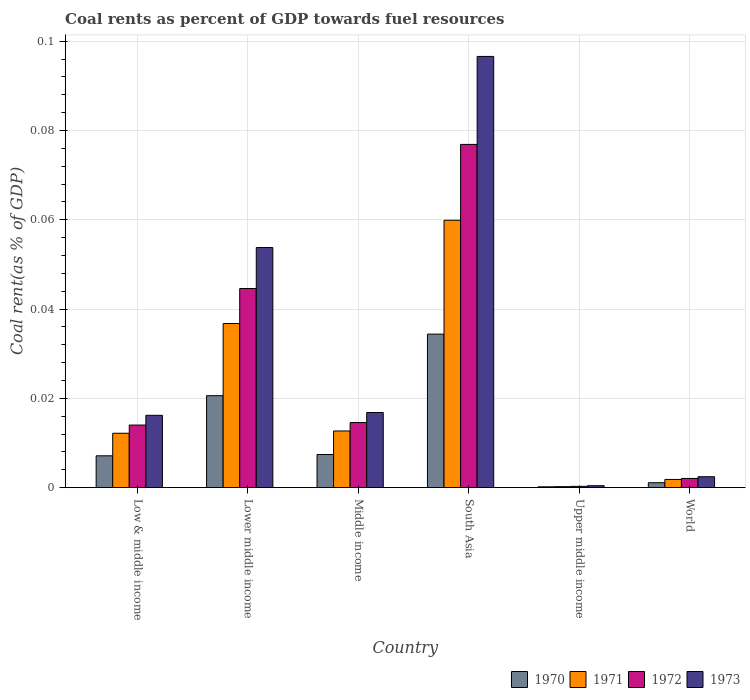How many different coloured bars are there?
Provide a short and direct response. 4. How many groups of bars are there?
Your answer should be very brief. 6. Are the number of bars on each tick of the X-axis equal?
Offer a terse response. Yes. What is the label of the 4th group of bars from the left?
Offer a very short reply. South Asia. What is the coal rent in 1972 in Upper middle income?
Keep it short and to the point. 0. Across all countries, what is the maximum coal rent in 1970?
Provide a short and direct response. 0.03. Across all countries, what is the minimum coal rent in 1971?
Your answer should be very brief. 0. In which country was the coal rent in 1970 maximum?
Offer a very short reply. South Asia. In which country was the coal rent in 1972 minimum?
Give a very brief answer. Upper middle income. What is the total coal rent in 1972 in the graph?
Ensure brevity in your answer.  0.15. What is the difference between the coal rent in 1972 in Lower middle income and that in Middle income?
Offer a very short reply. 0.03. What is the difference between the coal rent in 1972 in South Asia and the coal rent in 1970 in World?
Provide a succinct answer. 0.08. What is the average coal rent in 1972 per country?
Give a very brief answer. 0.03. What is the difference between the coal rent of/in 1970 and coal rent of/in 1973 in Low & middle income?
Your answer should be compact. -0.01. In how many countries, is the coal rent in 1970 greater than 0.092 %?
Keep it short and to the point. 0. What is the ratio of the coal rent in 1970 in South Asia to that in World?
Make the answer very short. 31.24. Is the coal rent in 1971 in Low & middle income less than that in South Asia?
Give a very brief answer. Yes. Is the difference between the coal rent in 1970 in Middle income and Upper middle income greater than the difference between the coal rent in 1973 in Middle income and Upper middle income?
Provide a succinct answer. No. What is the difference between the highest and the second highest coal rent in 1971?
Make the answer very short. 0.05. What is the difference between the highest and the lowest coal rent in 1972?
Give a very brief answer. 0.08. What does the 4th bar from the left in Low & middle income represents?
Your answer should be very brief. 1973. What does the 2nd bar from the right in World represents?
Ensure brevity in your answer.  1972. Is it the case that in every country, the sum of the coal rent in 1972 and coal rent in 1971 is greater than the coal rent in 1970?
Your answer should be very brief. Yes. How many bars are there?
Your answer should be compact. 24. Are the values on the major ticks of Y-axis written in scientific E-notation?
Your answer should be very brief. No. Does the graph contain any zero values?
Your response must be concise. No. Where does the legend appear in the graph?
Your answer should be very brief. Bottom right. How many legend labels are there?
Make the answer very short. 4. How are the legend labels stacked?
Your answer should be very brief. Horizontal. What is the title of the graph?
Offer a terse response. Coal rents as percent of GDP towards fuel resources. What is the label or title of the Y-axis?
Ensure brevity in your answer.  Coal rent(as % of GDP). What is the Coal rent(as % of GDP) in 1970 in Low & middle income?
Provide a short and direct response. 0.01. What is the Coal rent(as % of GDP) of 1971 in Low & middle income?
Ensure brevity in your answer.  0.01. What is the Coal rent(as % of GDP) in 1972 in Low & middle income?
Provide a short and direct response. 0.01. What is the Coal rent(as % of GDP) in 1973 in Low & middle income?
Offer a very short reply. 0.02. What is the Coal rent(as % of GDP) in 1970 in Lower middle income?
Provide a succinct answer. 0.02. What is the Coal rent(as % of GDP) in 1971 in Lower middle income?
Offer a terse response. 0.04. What is the Coal rent(as % of GDP) of 1972 in Lower middle income?
Your response must be concise. 0.04. What is the Coal rent(as % of GDP) of 1973 in Lower middle income?
Make the answer very short. 0.05. What is the Coal rent(as % of GDP) of 1970 in Middle income?
Keep it short and to the point. 0.01. What is the Coal rent(as % of GDP) in 1971 in Middle income?
Keep it short and to the point. 0.01. What is the Coal rent(as % of GDP) in 1972 in Middle income?
Make the answer very short. 0.01. What is the Coal rent(as % of GDP) of 1973 in Middle income?
Give a very brief answer. 0.02. What is the Coal rent(as % of GDP) in 1970 in South Asia?
Offer a very short reply. 0.03. What is the Coal rent(as % of GDP) in 1971 in South Asia?
Offer a very short reply. 0.06. What is the Coal rent(as % of GDP) of 1972 in South Asia?
Offer a terse response. 0.08. What is the Coal rent(as % of GDP) in 1973 in South Asia?
Offer a very short reply. 0.1. What is the Coal rent(as % of GDP) in 1970 in Upper middle income?
Your answer should be very brief. 0. What is the Coal rent(as % of GDP) of 1971 in Upper middle income?
Give a very brief answer. 0. What is the Coal rent(as % of GDP) of 1972 in Upper middle income?
Offer a terse response. 0. What is the Coal rent(as % of GDP) in 1973 in Upper middle income?
Provide a short and direct response. 0. What is the Coal rent(as % of GDP) in 1970 in World?
Ensure brevity in your answer.  0. What is the Coal rent(as % of GDP) of 1971 in World?
Your answer should be compact. 0. What is the Coal rent(as % of GDP) of 1972 in World?
Give a very brief answer. 0. What is the Coal rent(as % of GDP) in 1973 in World?
Your response must be concise. 0. Across all countries, what is the maximum Coal rent(as % of GDP) of 1970?
Your answer should be very brief. 0.03. Across all countries, what is the maximum Coal rent(as % of GDP) of 1971?
Your response must be concise. 0.06. Across all countries, what is the maximum Coal rent(as % of GDP) in 1972?
Offer a terse response. 0.08. Across all countries, what is the maximum Coal rent(as % of GDP) of 1973?
Keep it short and to the point. 0.1. Across all countries, what is the minimum Coal rent(as % of GDP) of 1970?
Your answer should be compact. 0. Across all countries, what is the minimum Coal rent(as % of GDP) in 1971?
Your answer should be very brief. 0. Across all countries, what is the minimum Coal rent(as % of GDP) of 1972?
Offer a terse response. 0. Across all countries, what is the minimum Coal rent(as % of GDP) of 1973?
Your answer should be compact. 0. What is the total Coal rent(as % of GDP) of 1970 in the graph?
Provide a succinct answer. 0.07. What is the total Coal rent(as % of GDP) of 1971 in the graph?
Offer a very short reply. 0.12. What is the total Coal rent(as % of GDP) in 1972 in the graph?
Your answer should be very brief. 0.15. What is the total Coal rent(as % of GDP) of 1973 in the graph?
Provide a short and direct response. 0.19. What is the difference between the Coal rent(as % of GDP) in 1970 in Low & middle income and that in Lower middle income?
Give a very brief answer. -0.01. What is the difference between the Coal rent(as % of GDP) of 1971 in Low & middle income and that in Lower middle income?
Provide a succinct answer. -0.02. What is the difference between the Coal rent(as % of GDP) in 1972 in Low & middle income and that in Lower middle income?
Offer a terse response. -0.03. What is the difference between the Coal rent(as % of GDP) of 1973 in Low & middle income and that in Lower middle income?
Give a very brief answer. -0.04. What is the difference between the Coal rent(as % of GDP) in 1970 in Low & middle income and that in Middle income?
Offer a terse response. -0. What is the difference between the Coal rent(as % of GDP) of 1971 in Low & middle income and that in Middle income?
Make the answer very short. -0. What is the difference between the Coal rent(as % of GDP) of 1972 in Low & middle income and that in Middle income?
Your answer should be very brief. -0. What is the difference between the Coal rent(as % of GDP) of 1973 in Low & middle income and that in Middle income?
Ensure brevity in your answer.  -0. What is the difference between the Coal rent(as % of GDP) of 1970 in Low & middle income and that in South Asia?
Give a very brief answer. -0.03. What is the difference between the Coal rent(as % of GDP) in 1971 in Low & middle income and that in South Asia?
Your answer should be very brief. -0.05. What is the difference between the Coal rent(as % of GDP) of 1972 in Low & middle income and that in South Asia?
Provide a succinct answer. -0.06. What is the difference between the Coal rent(as % of GDP) of 1973 in Low & middle income and that in South Asia?
Offer a very short reply. -0.08. What is the difference between the Coal rent(as % of GDP) in 1970 in Low & middle income and that in Upper middle income?
Your answer should be very brief. 0.01. What is the difference between the Coal rent(as % of GDP) in 1971 in Low & middle income and that in Upper middle income?
Keep it short and to the point. 0.01. What is the difference between the Coal rent(as % of GDP) in 1972 in Low & middle income and that in Upper middle income?
Your answer should be compact. 0.01. What is the difference between the Coal rent(as % of GDP) of 1973 in Low & middle income and that in Upper middle income?
Make the answer very short. 0.02. What is the difference between the Coal rent(as % of GDP) in 1970 in Low & middle income and that in World?
Your answer should be compact. 0.01. What is the difference between the Coal rent(as % of GDP) of 1971 in Low & middle income and that in World?
Offer a terse response. 0.01. What is the difference between the Coal rent(as % of GDP) of 1972 in Low & middle income and that in World?
Give a very brief answer. 0.01. What is the difference between the Coal rent(as % of GDP) of 1973 in Low & middle income and that in World?
Keep it short and to the point. 0.01. What is the difference between the Coal rent(as % of GDP) of 1970 in Lower middle income and that in Middle income?
Provide a succinct answer. 0.01. What is the difference between the Coal rent(as % of GDP) in 1971 in Lower middle income and that in Middle income?
Your answer should be very brief. 0.02. What is the difference between the Coal rent(as % of GDP) in 1973 in Lower middle income and that in Middle income?
Offer a very short reply. 0.04. What is the difference between the Coal rent(as % of GDP) of 1970 in Lower middle income and that in South Asia?
Offer a terse response. -0.01. What is the difference between the Coal rent(as % of GDP) in 1971 in Lower middle income and that in South Asia?
Offer a terse response. -0.02. What is the difference between the Coal rent(as % of GDP) in 1972 in Lower middle income and that in South Asia?
Offer a terse response. -0.03. What is the difference between the Coal rent(as % of GDP) in 1973 in Lower middle income and that in South Asia?
Your response must be concise. -0.04. What is the difference between the Coal rent(as % of GDP) of 1970 in Lower middle income and that in Upper middle income?
Offer a very short reply. 0.02. What is the difference between the Coal rent(as % of GDP) in 1971 in Lower middle income and that in Upper middle income?
Your answer should be compact. 0.04. What is the difference between the Coal rent(as % of GDP) in 1972 in Lower middle income and that in Upper middle income?
Ensure brevity in your answer.  0.04. What is the difference between the Coal rent(as % of GDP) in 1973 in Lower middle income and that in Upper middle income?
Offer a very short reply. 0.05. What is the difference between the Coal rent(as % of GDP) of 1970 in Lower middle income and that in World?
Make the answer very short. 0.02. What is the difference between the Coal rent(as % of GDP) of 1971 in Lower middle income and that in World?
Your answer should be very brief. 0.03. What is the difference between the Coal rent(as % of GDP) of 1972 in Lower middle income and that in World?
Provide a succinct answer. 0.04. What is the difference between the Coal rent(as % of GDP) of 1973 in Lower middle income and that in World?
Provide a short and direct response. 0.05. What is the difference between the Coal rent(as % of GDP) in 1970 in Middle income and that in South Asia?
Keep it short and to the point. -0.03. What is the difference between the Coal rent(as % of GDP) in 1971 in Middle income and that in South Asia?
Offer a terse response. -0.05. What is the difference between the Coal rent(as % of GDP) of 1972 in Middle income and that in South Asia?
Offer a very short reply. -0.06. What is the difference between the Coal rent(as % of GDP) in 1973 in Middle income and that in South Asia?
Make the answer very short. -0.08. What is the difference between the Coal rent(as % of GDP) of 1970 in Middle income and that in Upper middle income?
Provide a succinct answer. 0.01. What is the difference between the Coal rent(as % of GDP) in 1971 in Middle income and that in Upper middle income?
Make the answer very short. 0.01. What is the difference between the Coal rent(as % of GDP) in 1972 in Middle income and that in Upper middle income?
Offer a terse response. 0.01. What is the difference between the Coal rent(as % of GDP) in 1973 in Middle income and that in Upper middle income?
Keep it short and to the point. 0.02. What is the difference between the Coal rent(as % of GDP) of 1970 in Middle income and that in World?
Provide a short and direct response. 0.01. What is the difference between the Coal rent(as % of GDP) of 1971 in Middle income and that in World?
Your answer should be very brief. 0.01. What is the difference between the Coal rent(as % of GDP) of 1972 in Middle income and that in World?
Your response must be concise. 0.01. What is the difference between the Coal rent(as % of GDP) of 1973 in Middle income and that in World?
Your answer should be compact. 0.01. What is the difference between the Coal rent(as % of GDP) of 1970 in South Asia and that in Upper middle income?
Offer a terse response. 0.03. What is the difference between the Coal rent(as % of GDP) in 1971 in South Asia and that in Upper middle income?
Offer a terse response. 0.06. What is the difference between the Coal rent(as % of GDP) of 1972 in South Asia and that in Upper middle income?
Ensure brevity in your answer.  0.08. What is the difference between the Coal rent(as % of GDP) of 1973 in South Asia and that in Upper middle income?
Your response must be concise. 0.1. What is the difference between the Coal rent(as % of GDP) in 1971 in South Asia and that in World?
Provide a succinct answer. 0.06. What is the difference between the Coal rent(as % of GDP) in 1972 in South Asia and that in World?
Offer a very short reply. 0.07. What is the difference between the Coal rent(as % of GDP) in 1973 in South Asia and that in World?
Keep it short and to the point. 0.09. What is the difference between the Coal rent(as % of GDP) of 1970 in Upper middle income and that in World?
Your answer should be very brief. -0. What is the difference between the Coal rent(as % of GDP) of 1971 in Upper middle income and that in World?
Your answer should be very brief. -0. What is the difference between the Coal rent(as % of GDP) of 1972 in Upper middle income and that in World?
Offer a very short reply. -0. What is the difference between the Coal rent(as % of GDP) in 1973 in Upper middle income and that in World?
Provide a succinct answer. -0. What is the difference between the Coal rent(as % of GDP) in 1970 in Low & middle income and the Coal rent(as % of GDP) in 1971 in Lower middle income?
Provide a succinct answer. -0.03. What is the difference between the Coal rent(as % of GDP) of 1970 in Low & middle income and the Coal rent(as % of GDP) of 1972 in Lower middle income?
Offer a terse response. -0.04. What is the difference between the Coal rent(as % of GDP) of 1970 in Low & middle income and the Coal rent(as % of GDP) of 1973 in Lower middle income?
Your response must be concise. -0.05. What is the difference between the Coal rent(as % of GDP) of 1971 in Low & middle income and the Coal rent(as % of GDP) of 1972 in Lower middle income?
Provide a short and direct response. -0.03. What is the difference between the Coal rent(as % of GDP) of 1971 in Low & middle income and the Coal rent(as % of GDP) of 1973 in Lower middle income?
Provide a succinct answer. -0.04. What is the difference between the Coal rent(as % of GDP) in 1972 in Low & middle income and the Coal rent(as % of GDP) in 1973 in Lower middle income?
Your answer should be very brief. -0.04. What is the difference between the Coal rent(as % of GDP) of 1970 in Low & middle income and the Coal rent(as % of GDP) of 1971 in Middle income?
Ensure brevity in your answer.  -0.01. What is the difference between the Coal rent(as % of GDP) in 1970 in Low & middle income and the Coal rent(as % of GDP) in 1972 in Middle income?
Provide a short and direct response. -0.01. What is the difference between the Coal rent(as % of GDP) in 1970 in Low & middle income and the Coal rent(as % of GDP) in 1973 in Middle income?
Your response must be concise. -0.01. What is the difference between the Coal rent(as % of GDP) of 1971 in Low & middle income and the Coal rent(as % of GDP) of 1972 in Middle income?
Make the answer very short. -0. What is the difference between the Coal rent(as % of GDP) of 1971 in Low & middle income and the Coal rent(as % of GDP) of 1973 in Middle income?
Keep it short and to the point. -0. What is the difference between the Coal rent(as % of GDP) of 1972 in Low & middle income and the Coal rent(as % of GDP) of 1973 in Middle income?
Your answer should be compact. -0. What is the difference between the Coal rent(as % of GDP) of 1970 in Low & middle income and the Coal rent(as % of GDP) of 1971 in South Asia?
Give a very brief answer. -0.05. What is the difference between the Coal rent(as % of GDP) in 1970 in Low & middle income and the Coal rent(as % of GDP) in 1972 in South Asia?
Your response must be concise. -0.07. What is the difference between the Coal rent(as % of GDP) in 1970 in Low & middle income and the Coal rent(as % of GDP) in 1973 in South Asia?
Offer a very short reply. -0.09. What is the difference between the Coal rent(as % of GDP) in 1971 in Low & middle income and the Coal rent(as % of GDP) in 1972 in South Asia?
Keep it short and to the point. -0.06. What is the difference between the Coal rent(as % of GDP) of 1971 in Low & middle income and the Coal rent(as % of GDP) of 1973 in South Asia?
Provide a short and direct response. -0.08. What is the difference between the Coal rent(as % of GDP) in 1972 in Low & middle income and the Coal rent(as % of GDP) in 1973 in South Asia?
Provide a short and direct response. -0.08. What is the difference between the Coal rent(as % of GDP) of 1970 in Low & middle income and the Coal rent(as % of GDP) of 1971 in Upper middle income?
Give a very brief answer. 0.01. What is the difference between the Coal rent(as % of GDP) of 1970 in Low & middle income and the Coal rent(as % of GDP) of 1972 in Upper middle income?
Your answer should be compact. 0.01. What is the difference between the Coal rent(as % of GDP) in 1970 in Low & middle income and the Coal rent(as % of GDP) in 1973 in Upper middle income?
Give a very brief answer. 0.01. What is the difference between the Coal rent(as % of GDP) of 1971 in Low & middle income and the Coal rent(as % of GDP) of 1972 in Upper middle income?
Keep it short and to the point. 0.01. What is the difference between the Coal rent(as % of GDP) of 1971 in Low & middle income and the Coal rent(as % of GDP) of 1973 in Upper middle income?
Provide a succinct answer. 0.01. What is the difference between the Coal rent(as % of GDP) in 1972 in Low & middle income and the Coal rent(as % of GDP) in 1973 in Upper middle income?
Your response must be concise. 0.01. What is the difference between the Coal rent(as % of GDP) in 1970 in Low & middle income and the Coal rent(as % of GDP) in 1971 in World?
Provide a succinct answer. 0.01. What is the difference between the Coal rent(as % of GDP) of 1970 in Low & middle income and the Coal rent(as % of GDP) of 1972 in World?
Give a very brief answer. 0.01. What is the difference between the Coal rent(as % of GDP) of 1970 in Low & middle income and the Coal rent(as % of GDP) of 1973 in World?
Give a very brief answer. 0. What is the difference between the Coal rent(as % of GDP) in 1971 in Low & middle income and the Coal rent(as % of GDP) in 1972 in World?
Provide a succinct answer. 0.01. What is the difference between the Coal rent(as % of GDP) of 1971 in Low & middle income and the Coal rent(as % of GDP) of 1973 in World?
Keep it short and to the point. 0.01. What is the difference between the Coal rent(as % of GDP) of 1972 in Low & middle income and the Coal rent(as % of GDP) of 1973 in World?
Your answer should be compact. 0.01. What is the difference between the Coal rent(as % of GDP) in 1970 in Lower middle income and the Coal rent(as % of GDP) in 1971 in Middle income?
Your answer should be compact. 0.01. What is the difference between the Coal rent(as % of GDP) of 1970 in Lower middle income and the Coal rent(as % of GDP) of 1972 in Middle income?
Offer a very short reply. 0.01. What is the difference between the Coal rent(as % of GDP) of 1970 in Lower middle income and the Coal rent(as % of GDP) of 1973 in Middle income?
Your response must be concise. 0. What is the difference between the Coal rent(as % of GDP) in 1971 in Lower middle income and the Coal rent(as % of GDP) in 1972 in Middle income?
Offer a very short reply. 0.02. What is the difference between the Coal rent(as % of GDP) in 1971 in Lower middle income and the Coal rent(as % of GDP) in 1973 in Middle income?
Make the answer very short. 0.02. What is the difference between the Coal rent(as % of GDP) of 1972 in Lower middle income and the Coal rent(as % of GDP) of 1973 in Middle income?
Make the answer very short. 0.03. What is the difference between the Coal rent(as % of GDP) in 1970 in Lower middle income and the Coal rent(as % of GDP) in 1971 in South Asia?
Provide a succinct answer. -0.04. What is the difference between the Coal rent(as % of GDP) of 1970 in Lower middle income and the Coal rent(as % of GDP) of 1972 in South Asia?
Give a very brief answer. -0.06. What is the difference between the Coal rent(as % of GDP) of 1970 in Lower middle income and the Coal rent(as % of GDP) of 1973 in South Asia?
Your answer should be compact. -0.08. What is the difference between the Coal rent(as % of GDP) of 1971 in Lower middle income and the Coal rent(as % of GDP) of 1972 in South Asia?
Offer a very short reply. -0.04. What is the difference between the Coal rent(as % of GDP) in 1971 in Lower middle income and the Coal rent(as % of GDP) in 1973 in South Asia?
Offer a very short reply. -0.06. What is the difference between the Coal rent(as % of GDP) in 1972 in Lower middle income and the Coal rent(as % of GDP) in 1973 in South Asia?
Provide a succinct answer. -0.05. What is the difference between the Coal rent(as % of GDP) in 1970 in Lower middle income and the Coal rent(as % of GDP) in 1971 in Upper middle income?
Your answer should be compact. 0.02. What is the difference between the Coal rent(as % of GDP) in 1970 in Lower middle income and the Coal rent(as % of GDP) in 1972 in Upper middle income?
Give a very brief answer. 0.02. What is the difference between the Coal rent(as % of GDP) in 1970 in Lower middle income and the Coal rent(as % of GDP) in 1973 in Upper middle income?
Ensure brevity in your answer.  0.02. What is the difference between the Coal rent(as % of GDP) in 1971 in Lower middle income and the Coal rent(as % of GDP) in 1972 in Upper middle income?
Your response must be concise. 0.04. What is the difference between the Coal rent(as % of GDP) of 1971 in Lower middle income and the Coal rent(as % of GDP) of 1973 in Upper middle income?
Give a very brief answer. 0.04. What is the difference between the Coal rent(as % of GDP) in 1972 in Lower middle income and the Coal rent(as % of GDP) in 1973 in Upper middle income?
Give a very brief answer. 0.04. What is the difference between the Coal rent(as % of GDP) of 1970 in Lower middle income and the Coal rent(as % of GDP) of 1971 in World?
Provide a succinct answer. 0.02. What is the difference between the Coal rent(as % of GDP) of 1970 in Lower middle income and the Coal rent(as % of GDP) of 1972 in World?
Offer a very short reply. 0.02. What is the difference between the Coal rent(as % of GDP) in 1970 in Lower middle income and the Coal rent(as % of GDP) in 1973 in World?
Provide a short and direct response. 0.02. What is the difference between the Coal rent(as % of GDP) in 1971 in Lower middle income and the Coal rent(as % of GDP) in 1972 in World?
Your response must be concise. 0.03. What is the difference between the Coal rent(as % of GDP) of 1971 in Lower middle income and the Coal rent(as % of GDP) of 1973 in World?
Offer a terse response. 0.03. What is the difference between the Coal rent(as % of GDP) of 1972 in Lower middle income and the Coal rent(as % of GDP) of 1973 in World?
Your response must be concise. 0.04. What is the difference between the Coal rent(as % of GDP) in 1970 in Middle income and the Coal rent(as % of GDP) in 1971 in South Asia?
Your answer should be very brief. -0.05. What is the difference between the Coal rent(as % of GDP) in 1970 in Middle income and the Coal rent(as % of GDP) in 1972 in South Asia?
Provide a succinct answer. -0.07. What is the difference between the Coal rent(as % of GDP) of 1970 in Middle income and the Coal rent(as % of GDP) of 1973 in South Asia?
Make the answer very short. -0.09. What is the difference between the Coal rent(as % of GDP) in 1971 in Middle income and the Coal rent(as % of GDP) in 1972 in South Asia?
Provide a succinct answer. -0.06. What is the difference between the Coal rent(as % of GDP) in 1971 in Middle income and the Coal rent(as % of GDP) in 1973 in South Asia?
Provide a succinct answer. -0.08. What is the difference between the Coal rent(as % of GDP) of 1972 in Middle income and the Coal rent(as % of GDP) of 1973 in South Asia?
Keep it short and to the point. -0.08. What is the difference between the Coal rent(as % of GDP) of 1970 in Middle income and the Coal rent(as % of GDP) of 1971 in Upper middle income?
Keep it short and to the point. 0.01. What is the difference between the Coal rent(as % of GDP) in 1970 in Middle income and the Coal rent(as % of GDP) in 1972 in Upper middle income?
Offer a very short reply. 0.01. What is the difference between the Coal rent(as % of GDP) of 1970 in Middle income and the Coal rent(as % of GDP) of 1973 in Upper middle income?
Give a very brief answer. 0.01. What is the difference between the Coal rent(as % of GDP) of 1971 in Middle income and the Coal rent(as % of GDP) of 1972 in Upper middle income?
Offer a terse response. 0.01. What is the difference between the Coal rent(as % of GDP) of 1971 in Middle income and the Coal rent(as % of GDP) of 1973 in Upper middle income?
Ensure brevity in your answer.  0.01. What is the difference between the Coal rent(as % of GDP) in 1972 in Middle income and the Coal rent(as % of GDP) in 1973 in Upper middle income?
Give a very brief answer. 0.01. What is the difference between the Coal rent(as % of GDP) in 1970 in Middle income and the Coal rent(as % of GDP) in 1971 in World?
Offer a terse response. 0.01. What is the difference between the Coal rent(as % of GDP) in 1970 in Middle income and the Coal rent(as % of GDP) in 1972 in World?
Give a very brief answer. 0.01. What is the difference between the Coal rent(as % of GDP) in 1970 in Middle income and the Coal rent(as % of GDP) in 1973 in World?
Your answer should be compact. 0.01. What is the difference between the Coal rent(as % of GDP) in 1971 in Middle income and the Coal rent(as % of GDP) in 1972 in World?
Offer a very short reply. 0.01. What is the difference between the Coal rent(as % of GDP) of 1971 in Middle income and the Coal rent(as % of GDP) of 1973 in World?
Your answer should be very brief. 0.01. What is the difference between the Coal rent(as % of GDP) in 1972 in Middle income and the Coal rent(as % of GDP) in 1973 in World?
Provide a succinct answer. 0.01. What is the difference between the Coal rent(as % of GDP) in 1970 in South Asia and the Coal rent(as % of GDP) in 1971 in Upper middle income?
Keep it short and to the point. 0.03. What is the difference between the Coal rent(as % of GDP) in 1970 in South Asia and the Coal rent(as % of GDP) in 1972 in Upper middle income?
Make the answer very short. 0.03. What is the difference between the Coal rent(as % of GDP) of 1970 in South Asia and the Coal rent(as % of GDP) of 1973 in Upper middle income?
Ensure brevity in your answer.  0.03. What is the difference between the Coal rent(as % of GDP) of 1971 in South Asia and the Coal rent(as % of GDP) of 1972 in Upper middle income?
Your answer should be very brief. 0.06. What is the difference between the Coal rent(as % of GDP) in 1971 in South Asia and the Coal rent(as % of GDP) in 1973 in Upper middle income?
Offer a terse response. 0.06. What is the difference between the Coal rent(as % of GDP) in 1972 in South Asia and the Coal rent(as % of GDP) in 1973 in Upper middle income?
Your answer should be compact. 0.08. What is the difference between the Coal rent(as % of GDP) in 1970 in South Asia and the Coal rent(as % of GDP) in 1971 in World?
Provide a succinct answer. 0.03. What is the difference between the Coal rent(as % of GDP) of 1970 in South Asia and the Coal rent(as % of GDP) of 1972 in World?
Give a very brief answer. 0.03. What is the difference between the Coal rent(as % of GDP) in 1970 in South Asia and the Coal rent(as % of GDP) in 1973 in World?
Your answer should be very brief. 0.03. What is the difference between the Coal rent(as % of GDP) in 1971 in South Asia and the Coal rent(as % of GDP) in 1972 in World?
Your answer should be very brief. 0.06. What is the difference between the Coal rent(as % of GDP) in 1971 in South Asia and the Coal rent(as % of GDP) in 1973 in World?
Ensure brevity in your answer.  0.06. What is the difference between the Coal rent(as % of GDP) in 1972 in South Asia and the Coal rent(as % of GDP) in 1973 in World?
Your answer should be compact. 0.07. What is the difference between the Coal rent(as % of GDP) of 1970 in Upper middle income and the Coal rent(as % of GDP) of 1971 in World?
Make the answer very short. -0. What is the difference between the Coal rent(as % of GDP) of 1970 in Upper middle income and the Coal rent(as % of GDP) of 1972 in World?
Your answer should be compact. -0. What is the difference between the Coal rent(as % of GDP) of 1970 in Upper middle income and the Coal rent(as % of GDP) of 1973 in World?
Give a very brief answer. -0. What is the difference between the Coal rent(as % of GDP) of 1971 in Upper middle income and the Coal rent(as % of GDP) of 1972 in World?
Provide a short and direct response. -0. What is the difference between the Coal rent(as % of GDP) of 1971 in Upper middle income and the Coal rent(as % of GDP) of 1973 in World?
Make the answer very short. -0. What is the difference between the Coal rent(as % of GDP) of 1972 in Upper middle income and the Coal rent(as % of GDP) of 1973 in World?
Your answer should be compact. -0. What is the average Coal rent(as % of GDP) in 1970 per country?
Keep it short and to the point. 0.01. What is the average Coal rent(as % of GDP) in 1971 per country?
Your response must be concise. 0.02. What is the average Coal rent(as % of GDP) in 1972 per country?
Offer a very short reply. 0.03. What is the average Coal rent(as % of GDP) of 1973 per country?
Offer a very short reply. 0.03. What is the difference between the Coal rent(as % of GDP) in 1970 and Coal rent(as % of GDP) in 1971 in Low & middle income?
Your answer should be very brief. -0.01. What is the difference between the Coal rent(as % of GDP) of 1970 and Coal rent(as % of GDP) of 1972 in Low & middle income?
Offer a terse response. -0.01. What is the difference between the Coal rent(as % of GDP) of 1970 and Coal rent(as % of GDP) of 1973 in Low & middle income?
Offer a very short reply. -0.01. What is the difference between the Coal rent(as % of GDP) in 1971 and Coal rent(as % of GDP) in 1972 in Low & middle income?
Provide a short and direct response. -0. What is the difference between the Coal rent(as % of GDP) of 1971 and Coal rent(as % of GDP) of 1973 in Low & middle income?
Give a very brief answer. -0. What is the difference between the Coal rent(as % of GDP) in 1972 and Coal rent(as % of GDP) in 1973 in Low & middle income?
Your response must be concise. -0. What is the difference between the Coal rent(as % of GDP) in 1970 and Coal rent(as % of GDP) in 1971 in Lower middle income?
Keep it short and to the point. -0.02. What is the difference between the Coal rent(as % of GDP) of 1970 and Coal rent(as % of GDP) of 1972 in Lower middle income?
Your response must be concise. -0.02. What is the difference between the Coal rent(as % of GDP) in 1970 and Coal rent(as % of GDP) in 1973 in Lower middle income?
Your response must be concise. -0.03. What is the difference between the Coal rent(as % of GDP) in 1971 and Coal rent(as % of GDP) in 1972 in Lower middle income?
Your answer should be compact. -0.01. What is the difference between the Coal rent(as % of GDP) in 1971 and Coal rent(as % of GDP) in 1973 in Lower middle income?
Your answer should be compact. -0.02. What is the difference between the Coal rent(as % of GDP) of 1972 and Coal rent(as % of GDP) of 1973 in Lower middle income?
Make the answer very short. -0.01. What is the difference between the Coal rent(as % of GDP) in 1970 and Coal rent(as % of GDP) in 1971 in Middle income?
Provide a succinct answer. -0.01. What is the difference between the Coal rent(as % of GDP) of 1970 and Coal rent(as % of GDP) of 1972 in Middle income?
Your answer should be very brief. -0.01. What is the difference between the Coal rent(as % of GDP) of 1970 and Coal rent(as % of GDP) of 1973 in Middle income?
Provide a short and direct response. -0.01. What is the difference between the Coal rent(as % of GDP) in 1971 and Coal rent(as % of GDP) in 1972 in Middle income?
Give a very brief answer. -0. What is the difference between the Coal rent(as % of GDP) of 1971 and Coal rent(as % of GDP) of 1973 in Middle income?
Offer a very short reply. -0. What is the difference between the Coal rent(as % of GDP) in 1972 and Coal rent(as % of GDP) in 1973 in Middle income?
Give a very brief answer. -0. What is the difference between the Coal rent(as % of GDP) in 1970 and Coal rent(as % of GDP) in 1971 in South Asia?
Provide a succinct answer. -0.03. What is the difference between the Coal rent(as % of GDP) in 1970 and Coal rent(as % of GDP) in 1972 in South Asia?
Give a very brief answer. -0.04. What is the difference between the Coal rent(as % of GDP) of 1970 and Coal rent(as % of GDP) of 1973 in South Asia?
Make the answer very short. -0.06. What is the difference between the Coal rent(as % of GDP) in 1971 and Coal rent(as % of GDP) in 1972 in South Asia?
Your answer should be very brief. -0.02. What is the difference between the Coal rent(as % of GDP) in 1971 and Coal rent(as % of GDP) in 1973 in South Asia?
Provide a succinct answer. -0.04. What is the difference between the Coal rent(as % of GDP) in 1972 and Coal rent(as % of GDP) in 1973 in South Asia?
Ensure brevity in your answer.  -0.02. What is the difference between the Coal rent(as % of GDP) of 1970 and Coal rent(as % of GDP) of 1971 in Upper middle income?
Make the answer very short. -0. What is the difference between the Coal rent(as % of GDP) of 1970 and Coal rent(as % of GDP) of 1972 in Upper middle income?
Keep it short and to the point. -0. What is the difference between the Coal rent(as % of GDP) of 1970 and Coal rent(as % of GDP) of 1973 in Upper middle income?
Provide a succinct answer. -0. What is the difference between the Coal rent(as % of GDP) in 1971 and Coal rent(as % of GDP) in 1972 in Upper middle income?
Keep it short and to the point. -0. What is the difference between the Coal rent(as % of GDP) of 1971 and Coal rent(as % of GDP) of 1973 in Upper middle income?
Offer a terse response. -0. What is the difference between the Coal rent(as % of GDP) in 1972 and Coal rent(as % of GDP) in 1973 in Upper middle income?
Provide a short and direct response. -0. What is the difference between the Coal rent(as % of GDP) in 1970 and Coal rent(as % of GDP) in 1971 in World?
Keep it short and to the point. -0. What is the difference between the Coal rent(as % of GDP) of 1970 and Coal rent(as % of GDP) of 1972 in World?
Provide a short and direct response. -0. What is the difference between the Coal rent(as % of GDP) in 1970 and Coal rent(as % of GDP) in 1973 in World?
Provide a succinct answer. -0. What is the difference between the Coal rent(as % of GDP) of 1971 and Coal rent(as % of GDP) of 1972 in World?
Your response must be concise. -0. What is the difference between the Coal rent(as % of GDP) in 1971 and Coal rent(as % of GDP) in 1973 in World?
Give a very brief answer. -0. What is the difference between the Coal rent(as % of GDP) of 1972 and Coal rent(as % of GDP) of 1973 in World?
Your response must be concise. -0. What is the ratio of the Coal rent(as % of GDP) in 1970 in Low & middle income to that in Lower middle income?
Your response must be concise. 0.35. What is the ratio of the Coal rent(as % of GDP) in 1971 in Low & middle income to that in Lower middle income?
Give a very brief answer. 0.33. What is the ratio of the Coal rent(as % of GDP) of 1972 in Low & middle income to that in Lower middle income?
Provide a short and direct response. 0.31. What is the ratio of the Coal rent(as % of GDP) of 1973 in Low & middle income to that in Lower middle income?
Ensure brevity in your answer.  0.3. What is the ratio of the Coal rent(as % of GDP) of 1970 in Low & middle income to that in Middle income?
Your response must be concise. 0.96. What is the ratio of the Coal rent(as % of GDP) of 1971 in Low & middle income to that in Middle income?
Keep it short and to the point. 0.96. What is the ratio of the Coal rent(as % of GDP) in 1972 in Low & middle income to that in Middle income?
Offer a terse response. 0.96. What is the ratio of the Coal rent(as % of GDP) of 1973 in Low & middle income to that in Middle income?
Offer a very short reply. 0.96. What is the ratio of the Coal rent(as % of GDP) in 1970 in Low & middle income to that in South Asia?
Offer a terse response. 0.21. What is the ratio of the Coal rent(as % of GDP) in 1971 in Low & middle income to that in South Asia?
Your answer should be very brief. 0.2. What is the ratio of the Coal rent(as % of GDP) of 1972 in Low & middle income to that in South Asia?
Keep it short and to the point. 0.18. What is the ratio of the Coal rent(as % of GDP) in 1973 in Low & middle income to that in South Asia?
Give a very brief answer. 0.17. What is the ratio of the Coal rent(as % of GDP) in 1970 in Low & middle income to that in Upper middle income?
Provide a short and direct response. 38.77. What is the ratio of the Coal rent(as % of GDP) in 1971 in Low & middle income to that in Upper middle income?
Your response must be concise. 55.66. What is the ratio of the Coal rent(as % of GDP) in 1972 in Low & middle income to that in Upper middle income?
Provide a succinct answer. 49.28. What is the ratio of the Coal rent(as % of GDP) of 1973 in Low & middle income to that in Upper middle income?
Give a very brief answer. 37.59. What is the ratio of the Coal rent(as % of GDP) of 1970 in Low & middle income to that in World?
Offer a very short reply. 6.48. What is the ratio of the Coal rent(as % of GDP) in 1971 in Low & middle income to that in World?
Ensure brevity in your answer.  6.65. What is the ratio of the Coal rent(as % of GDP) in 1972 in Low & middle income to that in World?
Ensure brevity in your answer.  6.82. What is the ratio of the Coal rent(as % of GDP) of 1973 in Low & middle income to that in World?
Ensure brevity in your answer.  6.65. What is the ratio of the Coal rent(as % of GDP) of 1970 in Lower middle income to that in Middle income?
Give a very brief answer. 2.78. What is the ratio of the Coal rent(as % of GDP) of 1971 in Lower middle income to that in Middle income?
Ensure brevity in your answer.  2.9. What is the ratio of the Coal rent(as % of GDP) of 1972 in Lower middle income to that in Middle income?
Provide a succinct answer. 3.06. What is the ratio of the Coal rent(as % of GDP) in 1973 in Lower middle income to that in Middle income?
Provide a succinct answer. 3.2. What is the ratio of the Coal rent(as % of GDP) of 1970 in Lower middle income to that in South Asia?
Your answer should be very brief. 0.6. What is the ratio of the Coal rent(as % of GDP) of 1971 in Lower middle income to that in South Asia?
Keep it short and to the point. 0.61. What is the ratio of the Coal rent(as % of GDP) in 1972 in Lower middle income to that in South Asia?
Offer a terse response. 0.58. What is the ratio of the Coal rent(as % of GDP) in 1973 in Lower middle income to that in South Asia?
Keep it short and to the point. 0.56. What is the ratio of the Coal rent(as % of GDP) in 1970 in Lower middle income to that in Upper middle income?
Provide a succinct answer. 112.03. What is the ratio of the Coal rent(as % of GDP) in 1971 in Lower middle income to that in Upper middle income?
Ensure brevity in your answer.  167.98. What is the ratio of the Coal rent(as % of GDP) in 1972 in Lower middle income to that in Upper middle income?
Your answer should be compact. 156.82. What is the ratio of the Coal rent(as % of GDP) of 1973 in Lower middle income to that in Upper middle income?
Offer a terse response. 124.82. What is the ratio of the Coal rent(as % of GDP) of 1970 in Lower middle income to that in World?
Offer a terse response. 18.71. What is the ratio of the Coal rent(as % of GDP) in 1971 in Lower middle income to that in World?
Offer a very short reply. 20.06. What is the ratio of the Coal rent(as % of GDP) in 1972 in Lower middle income to that in World?
Ensure brevity in your answer.  21.7. What is the ratio of the Coal rent(as % of GDP) of 1973 in Lower middle income to that in World?
Keep it short and to the point. 22.07. What is the ratio of the Coal rent(as % of GDP) in 1970 in Middle income to that in South Asia?
Make the answer very short. 0.22. What is the ratio of the Coal rent(as % of GDP) of 1971 in Middle income to that in South Asia?
Provide a short and direct response. 0.21. What is the ratio of the Coal rent(as % of GDP) in 1972 in Middle income to that in South Asia?
Ensure brevity in your answer.  0.19. What is the ratio of the Coal rent(as % of GDP) of 1973 in Middle income to that in South Asia?
Give a very brief answer. 0.17. What is the ratio of the Coal rent(as % of GDP) of 1970 in Middle income to that in Upper middle income?
Offer a very short reply. 40.36. What is the ratio of the Coal rent(as % of GDP) in 1971 in Middle income to that in Upper middle income?
Keep it short and to the point. 58.01. What is the ratio of the Coal rent(as % of GDP) of 1972 in Middle income to that in Upper middle income?
Ensure brevity in your answer.  51.25. What is the ratio of the Coal rent(as % of GDP) of 1973 in Middle income to that in Upper middle income?
Your response must be concise. 39.04. What is the ratio of the Coal rent(as % of GDP) in 1970 in Middle income to that in World?
Keep it short and to the point. 6.74. What is the ratio of the Coal rent(as % of GDP) in 1971 in Middle income to that in World?
Your response must be concise. 6.93. What is the ratio of the Coal rent(as % of GDP) of 1972 in Middle income to that in World?
Give a very brief answer. 7.09. What is the ratio of the Coal rent(as % of GDP) in 1973 in Middle income to that in World?
Give a very brief answer. 6.91. What is the ratio of the Coal rent(as % of GDP) in 1970 in South Asia to that in Upper middle income?
Give a very brief answer. 187.05. What is the ratio of the Coal rent(as % of GDP) of 1971 in South Asia to that in Upper middle income?
Make the answer very short. 273.74. What is the ratio of the Coal rent(as % of GDP) in 1972 in South Asia to that in Upper middle income?
Your answer should be compact. 270.32. What is the ratio of the Coal rent(as % of GDP) of 1973 in South Asia to that in Upper middle income?
Your answer should be compact. 224.18. What is the ratio of the Coal rent(as % of GDP) in 1970 in South Asia to that in World?
Provide a short and direct response. 31.24. What is the ratio of the Coal rent(as % of GDP) in 1971 in South Asia to that in World?
Keep it short and to the point. 32.69. What is the ratio of the Coal rent(as % of GDP) of 1972 in South Asia to that in World?
Give a very brief answer. 37.41. What is the ratio of the Coal rent(as % of GDP) in 1973 in South Asia to that in World?
Make the answer very short. 39.65. What is the ratio of the Coal rent(as % of GDP) in 1970 in Upper middle income to that in World?
Provide a short and direct response. 0.17. What is the ratio of the Coal rent(as % of GDP) in 1971 in Upper middle income to that in World?
Ensure brevity in your answer.  0.12. What is the ratio of the Coal rent(as % of GDP) in 1972 in Upper middle income to that in World?
Your answer should be very brief. 0.14. What is the ratio of the Coal rent(as % of GDP) in 1973 in Upper middle income to that in World?
Offer a terse response. 0.18. What is the difference between the highest and the second highest Coal rent(as % of GDP) in 1970?
Provide a short and direct response. 0.01. What is the difference between the highest and the second highest Coal rent(as % of GDP) in 1971?
Provide a short and direct response. 0.02. What is the difference between the highest and the second highest Coal rent(as % of GDP) in 1972?
Make the answer very short. 0.03. What is the difference between the highest and the second highest Coal rent(as % of GDP) in 1973?
Offer a terse response. 0.04. What is the difference between the highest and the lowest Coal rent(as % of GDP) of 1970?
Offer a terse response. 0.03. What is the difference between the highest and the lowest Coal rent(as % of GDP) in 1971?
Your answer should be compact. 0.06. What is the difference between the highest and the lowest Coal rent(as % of GDP) of 1972?
Offer a terse response. 0.08. What is the difference between the highest and the lowest Coal rent(as % of GDP) in 1973?
Offer a very short reply. 0.1. 